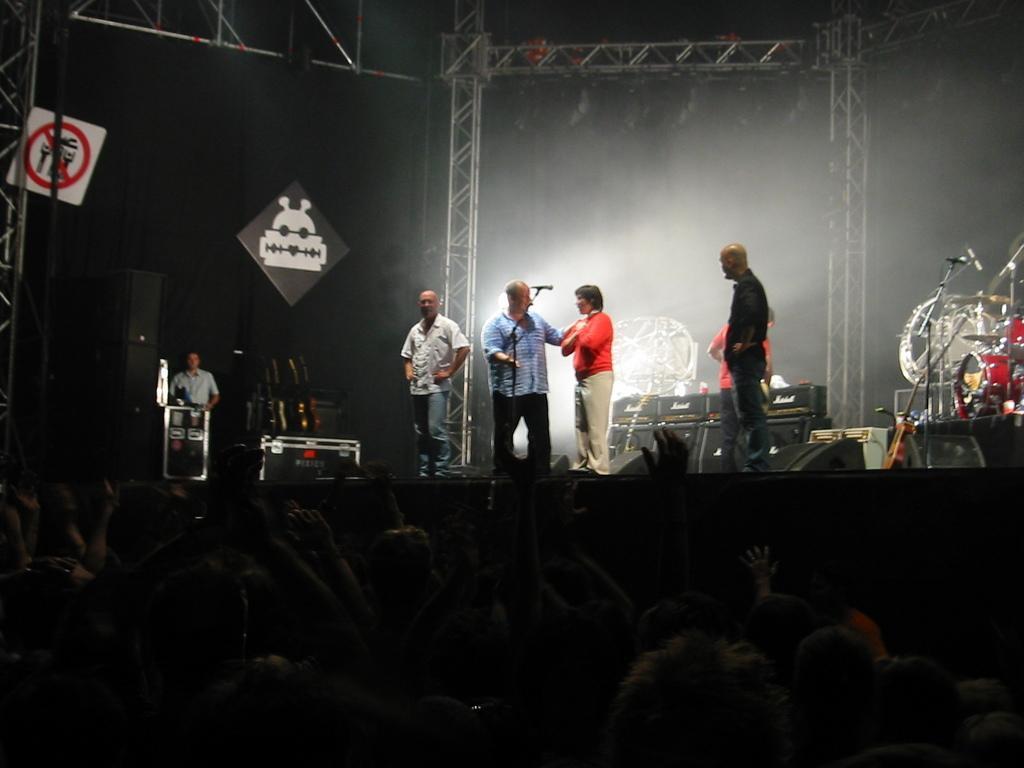How would you summarize this image in a sentence or two? In the image it looks like some music concert, there are few men standing on the stage and around them there are different music equipment, lights and speakers. In front of them there is a huge crowd. 